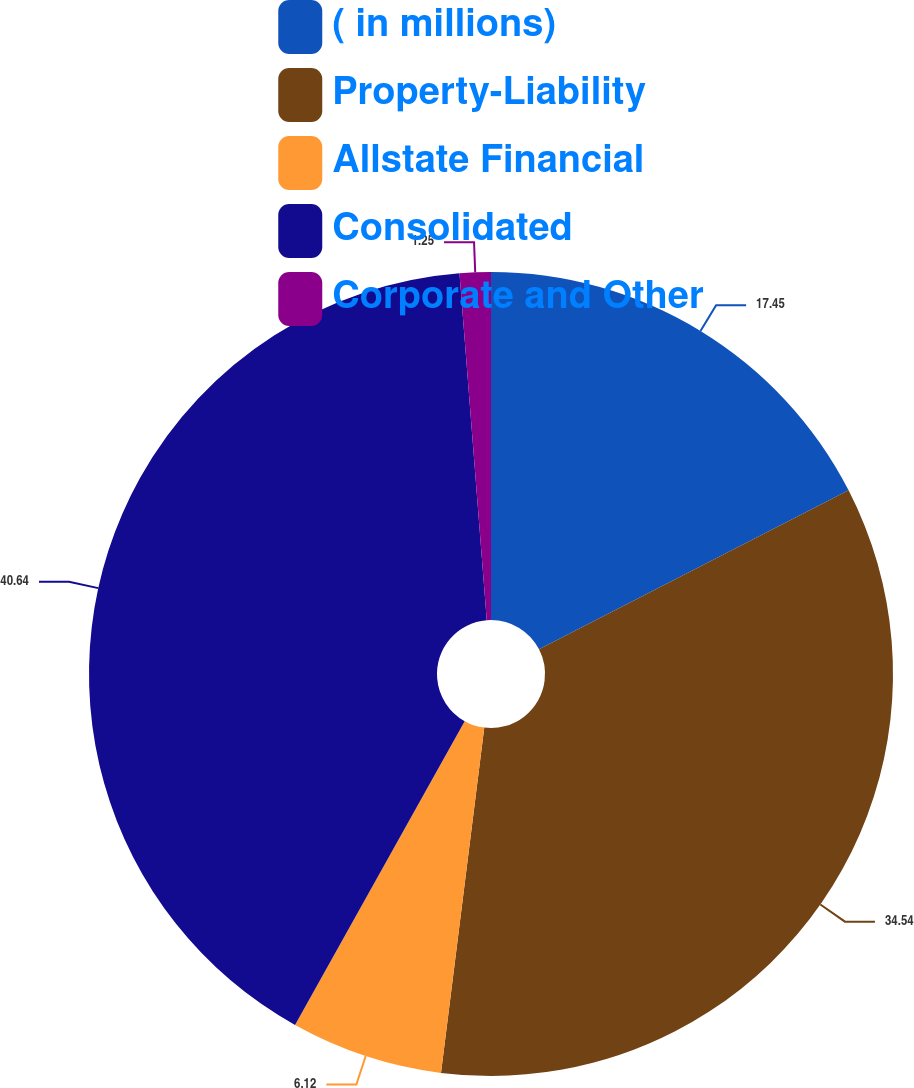Convert chart. <chart><loc_0><loc_0><loc_500><loc_500><pie_chart><fcel>( in millions)<fcel>Property-Liability<fcel>Allstate Financial<fcel>Consolidated<fcel>Corporate and Other<nl><fcel>17.45%<fcel>34.54%<fcel>6.12%<fcel>40.65%<fcel>1.25%<nl></chart> 